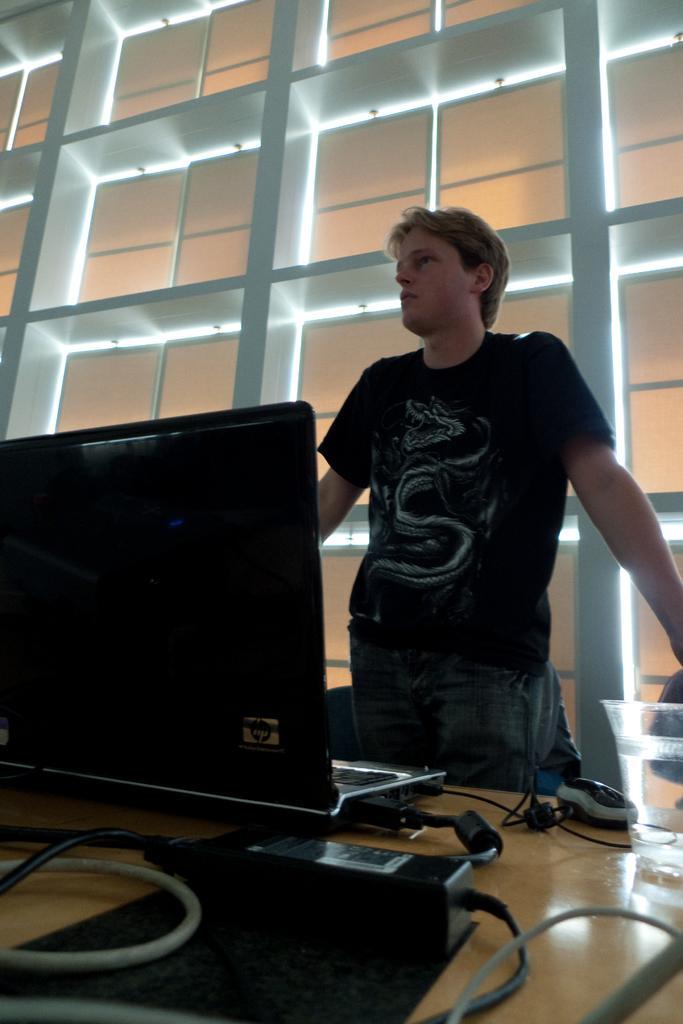Please provide a concise description of this image. In the foreground of this image, on a table, there is an adapter, cables, mouse and a laptop. Behind it, there is a man standing. In the background, it seems like a wall. 